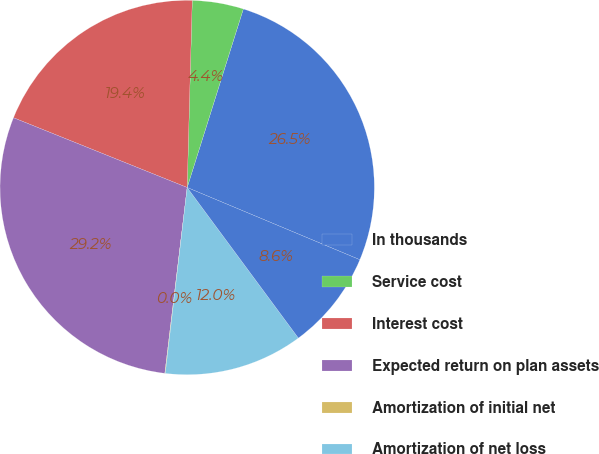Convert chart. <chart><loc_0><loc_0><loc_500><loc_500><pie_chart><fcel>In thousands<fcel>Service cost<fcel>Interest cost<fcel>Expected return on plan assets<fcel>Amortization of initial net<fcel>Amortization of net loss<fcel>Net periodic benefit cost<nl><fcel>26.45%<fcel>4.42%<fcel>19.35%<fcel>29.17%<fcel>0.04%<fcel>11.99%<fcel>8.57%<nl></chart> 